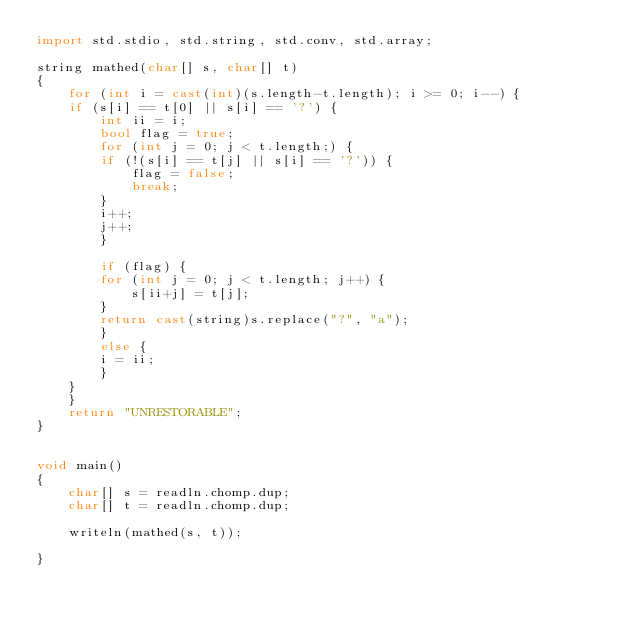Convert code to text. <code><loc_0><loc_0><loc_500><loc_500><_D_>import std.stdio, std.string, std.conv, std.array;

string mathed(char[] s, char[] t)
{
    for (int i = cast(int)(s.length-t.length); i >= 0; i--) {
	if (s[i] == t[0] || s[i] == '?') {
	    int ii = i;
	    bool flag = true;
	    for (int j = 0; j < t.length;) {
		if (!(s[i] == t[j] || s[i] == '?')) {
		    flag = false;
		    break;
		}
		i++;
		j++;
	    }

	    if (flag) {
		for (int j = 0; j < t.length; j++) {
		    s[ii+j] = t[j];
		}
		return cast(string)s.replace("?", "a");
	    }
	    else {
		i = ii;
	    }
	}
    }
    return "UNRESTORABLE";
}


void main()
{
    char[] s = readln.chomp.dup;
    char[] t = readln.chomp.dup;

    writeln(mathed(s, t));

}
</code> 